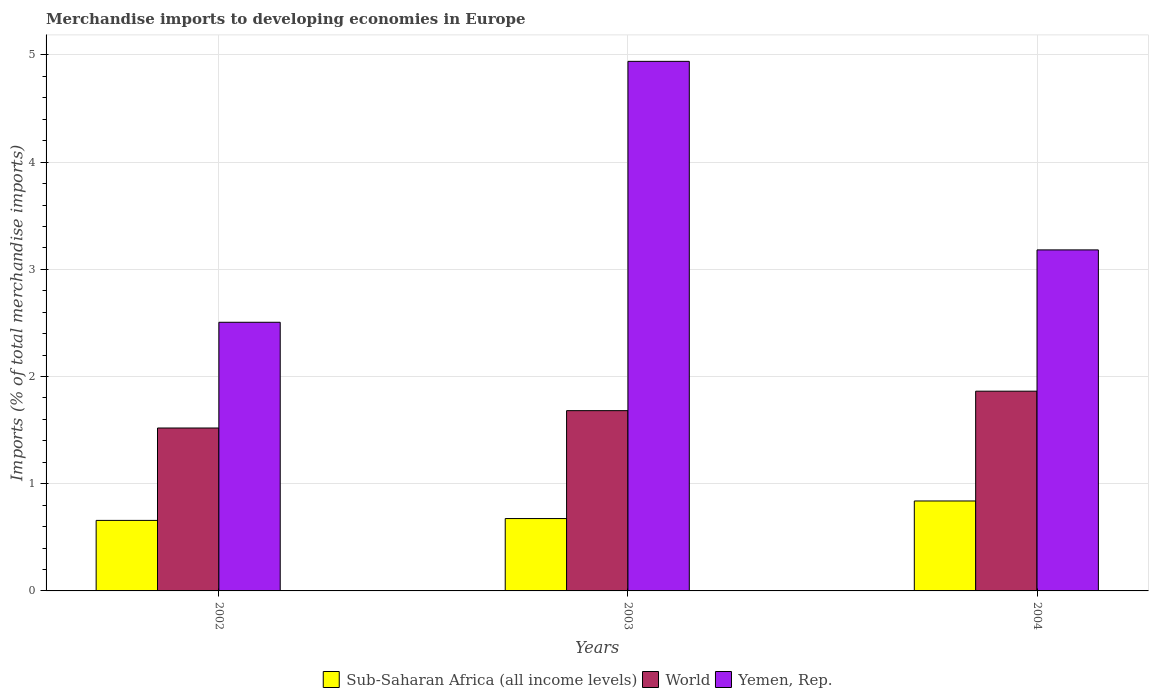How many groups of bars are there?
Ensure brevity in your answer.  3. Are the number of bars per tick equal to the number of legend labels?
Your answer should be very brief. Yes. How many bars are there on the 1st tick from the left?
Provide a succinct answer. 3. How many bars are there on the 3rd tick from the right?
Your response must be concise. 3. What is the label of the 3rd group of bars from the left?
Offer a very short reply. 2004. What is the percentage total merchandise imports in World in 2002?
Your answer should be very brief. 1.52. Across all years, what is the maximum percentage total merchandise imports in World?
Offer a terse response. 1.86. Across all years, what is the minimum percentage total merchandise imports in Sub-Saharan Africa (all income levels)?
Provide a short and direct response. 0.66. In which year was the percentage total merchandise imports in Sub-Saharan Africa (all income levels) maximum?
Your answer should be very brief. 2004. What is the total percentage total merchandise imports in World in the graph?
Offer a very short reply. 5.07. What is the difference between the percentage total merchandise imports in Sub-Saharan Africa (all income levels) in 2003 and that in 2004?
Provide a short and direct response. -0.16. What is the difference between the percentage total merchandise imports in World in 2002 and the percentage total merchandise imports in Sub-Saharan Africa (all income levels) in 2004?
Offer a very short reply. 0.68. What is the average percentage total merchandise imports in Yemen, Rep. per year?
Offer a terse response. 3.54. In the year 2002, what is the difference between the percentage total merchandise imports in Yemen, Rep. and percentage total merchandise imports in Sub-Saharan Africa (all income levels)?
Your answer should be compact. 1.85. What is the ratio of the percentage total merchandise imports in World in 2003 to that in 2004?
Your answer should be very brief. 0.9. What is the difference between the highest and the second highest percentage total merchandise imports in Sub-Saharan Africa (all income levels)?
Your answer should be compact. 0.16. What is the difference between the highest and the lowest percentage total merchandise imports in World?
Ensure brevity in your answer.  0.34. What does the 1st bar from the left in 2003 represents?
Your response must be concise. Sub-Saharan Africa (all income levels). What does the 1st bar from the right in 2002 represents?
Make the answer very short. Yemen, Rep. Are all the bars in the graph horizontal?
Your response must be concise. No. How many years are there in the graph?
Offer a very short reply. 3. What is the difference between two consecutive major ticks on the Y-axis?
Your response must be concise. 1. Does the graph contain grids?
Make the answer very short. Yes. What is the title of the graph?
Provide a succinct answer. Merchandise imports to developing economies in Europe. Does "Netherlands" appear as one of the legend labels in the graph?
Your response must be concise. No. What is the label or title of the X-axis?
Your response must be concise. Years. What is the label or title of the Y-axis?
Provide a short and direct response. Imports (% of total merchandise imports). What is the Imports (% of total merchandise imports) in Sub-Saharan Africa (all income levels) in 2002?
Your answer should be compact. 0.66. What is the Imports (% of total merchandise imports) in World in 2002?
Provide a short and direct response. 1.52. What is the Imports (% of total merchandise imports) in Yemen, Rep. in 2002?
Your answer should be very brief. 2.51. What is the Imports (% of total merchandise imports) in Sub-Saharan Africa (all income levels) in 2003?
Provide a succinct answer. 0.68. What is the Imports (% of total merchandise imports) in World in 2003?
Provide a short and direct response. 1.68. What is the Imports (% of total merchandise imports) of Yemen, Rep. in 2003?
Ensure brevity in your answer.  4.94. What is the Imports (% of total merchandise imports) of Sub-Saharan Africa (all income levels) in 2004?
Make the answer very short. 0.84. What is the Imports (% of total merchandise imports) in World in 2004?
Keep it short and to the point. 1.86. What is the Imports (% of total merchandise imports) in Yemen, Rep. in 2004?
Keep it short and to the point. 3.18. Across all years, what is the maximum Imports (% of total merchandise imports) in Sub-Saharan Africa (all income levels)?
Your response must be concise. 0.84. Across all years, what is the maximum Imports (% of total merchandise imports) of World?
Offer a very short reply. 1.86. Across all years, what is the maximum Imports (% of total merchandise imports) in Yemen, Rep.?
Provide a short and direct response. 4.94. Across all years, what is the minimum Imports (% of total merchandise imports) in Sub-Saharan Africa (all income levels)?
Give a very brief answer. 0.66. Across all years, what is the minimum Imports (% of total merchandise imports) in World?
Your response must be concise. 1.52. Across all years, what is the minimum Imports (% of total merchandise imports) in Yemen, Rep.?
Give a very brief answer. 2.51. What is the total Imports (% of total merchandise imports) in Sub-Saharan Africa (all income levels) in the graph?
Ensure brevity in your answer.  2.17. What is the total Imports (% of total merchandise imports) in World in the graph?
Your response must be concise. 5.07. What is the total Imports (% of total merchandise imports) in Yemen, Rep. in the graph?
Make the answer very short. 10.63. What is the difference between the Imports (% of total merchandise imports) in Sub-Saharan Africa (all income levels) in 2002 and that in 2003?
Offer a very short reply. -0.02. What is the difference between the Imports (% of total merchandise imports) of World in 2002 and that in 2003?
Your answer should be very brief. -0.16. What is the difference between the Imports (% of total merchandise imports) of Yemen, Rep. in 2002 and that in 2003?
Provide a succinct answer. -2.43. What is the difference between the Imports (% of total merchandise imports) in Sub-Saharan Africa (all income levels) in 2002 and that in 2004?
Make the answer very short. -0.18. What is the difference between the Imports (% of total merchandise imports) in World in 2002 and that in 2004?
Your answer should be very brief. -0.34. What is the difference between the Imports (% of total merchandise imports) in Yemen, Rep. in 2002 and that in 2004?
Keep it short and to the point. -0.68. What is the difference between the Imports (% of total merchandise imports) of Sub-Saharan Africa (all income levels) in 2003 and that in 2004?
Make the answer very short. -0.16. What is the difference between the Imports (% of total merchandise imports) in World in 2003 and that in 2004?
Make the answer very short. -0.18. What is the difference between the Imports (% of total merchandise imports) in Yemen, Rep. in 2003 and that in 2004?
Your response must be concise. 1.76. What is the difference between the Imports (% of total merchandise imports) in Sub-Saharan Africa (all income levels) in 2002 and the Imports (% of total merchandise imports) in World in 2003?
Provide a short and direct response. -1.02. What is the difference between the Imports (% of total merchandise imports) of Sub-Saharan Africa (all income levels) in 2002 and the Imports (% of total merchandise imports) of Yemen, Rep. in 2003?
Keep it short and to the point. -4.28. What is the difference between the Imports (% of total merchandise imports) in World in 2002 and the Imports (% of total merchandise imports) in Yemen, Rep. in 2003?
Give a very brief answer. -3.42. What is the difference between the Imports (% of total merchandise imports) in Sub-Saharan Africa (all income levels) in 2002 and the Imports (% of total merchandise imports) in World in 2004?
Make the answer very short. -1.21. What is the difference between the Imports (% of total merchandise imports) in Sub-Saharan Africa (all income levels) in 2002 and the Imports (% of total merchandise imports) in Yemen, Rep. in 2004?
Provide a succinct answer. -2.52. What is the difference between the Imports (% of total merchandise imports) in World in 2002 and the Imports (% of total merchandise imports) in Yemen, Rep. in 2004?
Give a very brief answer. -1.66. What is the difference between the Imports (% of total merchandise imports) in Sub-Saharan Africa (all income levels) in 2003 and the Imports (% of total merchandise imports) in World in 2004?
Offer a very short reply. -1.19. What is the difference between the Imports (% of total merchandise imports) in Sub-Saharan Africa (all income levels) in 2003 and the Imports (% of total merchandise imports) in Yemen, Rep. in 2004?
Give a very brief answer. -2.51. What is the difference between the Imports (% of total merchandise imports) in World in 2003 and the Imports (% of total merchandise imports) in Yemen, Rep. in 2004?
Your answer should be compact. -1.5. What is the average Imports (% of total merchandise imports) of Sub-Saharan Africa (all income levels) per year?
Give a very brief answer. 0.72. What is the average Imports (% of total merchandise imports) of World per year?
Offer a terse response. 1.69. What is the average Imports (% of total merchandise imports) of Yemen, Rep. per year?
Your response must be concise. 3.54. In the year 2002, what is the difference between the Imports (% of total merchandise imports) in Sub-Saharan Africa (all income levels) and Imports (% of total merchandise imports) in World?
Offer a terse response. -0.86. In the year 2002, what is the difference between the Imports (% of total merchandise imports) in Sub-Saharan Africa (all income levels) and Imports (% of total merchandise imports) in Yemen, Rep.?
Offer a terse response. -1.85. In the year 2002, what is the difference between the Imports (% of total merchandise imports) of World and Imports (% of total merchandise imports) of Yemen, Rep.?
Your answer should be compact. -0.99. In the year 2003, what is the difference between the Imports (% of total merchandise imports) in Sub-Saharan Africa (all income levels) and Imports (% of total merchandise imports) in World?
Provide a short and direct response. -1.01. In the year 2003, what is the difference between the Imports (% of total merchandise imports) in Sub-Saharan Africa (all income levels) and Imports (% of total merchandise imports) in Yemen, Rep.?
Offer a terse response. -4.27. In the year 2003, what is the difference between the Imports (% of total merchandise imports) of World and Imports (% of total merchandise imports) of Yemen, Rep.?
Provide a succinct answer. -3.26. In the year 2004, what is the difference between the Imports (% of total merchandise imports) in Sub-Saharan Africa (all income levels) and Imports (% of total merchandise imports) in World?
Ensure brevity in your answer.  -1.02. In the year 2004, what is the difference between the Imports (% of total merchandise imports) in Sub-Saharan Africa (all income levels) and Imports (% of total merchandise imports) in Yemen, Rep.?
Give a very brief answer. -2.34. In the year 2004, what is the difference between the Imports (% of total merchandise imports) of World and Imports (% of total merchandise imports) of Yemen, Rep.?
Ensure brevity in your answer.  -1.32. What is the ratio of the Imports (% of total merchandise imports) in Sub-Saharan Africa (all income levels) in 2002 to that in 2003?
Your answer should be compact. 0.97. What is the ratio of the Imports (% of total merchandise imports) in World in 2002 to that in 2003?
Your answer should be compact. 0.9. What is the ratio of the Imports (% of total merchandise imports) in Yemen, Rep. in 2002 to that in 2003?
Ensure brevity in your answer.  0.51. What is the ratio of the Imports (% of total merchandise imports) of Sub-Saharan Africa (all income levels) in 2002 to that in 2004?
Your answer should be very brief. 0.78. What is the ratio of the Imports (% of total merchandise imports) in World in 2002 to that in 2004?
Make the answer very short. 0.82. What is the ratio of the Imports (% of total merchandise imports) in Yemen, Rep. in 2002 to that in 2004?
Your answer should be compact. 0.79. What is the ratio of the Imports (% of total merchandise imports) in Sub-Saharan Africa (all income levels) in 2003 to that in 2004?
Your answer should be compact. 0.8. What is the ratio of the Imports (% of total merchandise imports) of World in 2003 to that in 2004?
Your response must be concise. 0.9. What is the ratio of the Imports (% of total merchandise imports) of Yemen, Rep. in 2003 to that in 2004?
Provide a succinct answer. 1.55. What is the difference between the highest and the second highest Imports (% of total merchandise imports) of Sub-Saharan Africa (all income levels)?
Provide a succinct answer. 0.16. What is the difference between the highest and the second highest Imports (% of total merchandise imports) of World?
Give a very brief answer. 0.18. What is the difference between the highest and the second highest Imports (% of total merchandise imports) in Yemen, Rep.?
Your response must be concise. 1.76. What is the difference between the highest and the lowest Imports (% of total merchandise imports) in Sub-Saharan Africa (all income levels)?
Your answer should be compact. 0.18. What is the difference between the highest and the lowest Imports (% of total merchandise imports) of World?
Give a very brief answer. 0.34. What is the difference between the highest and the lowest Imports (% of total merchandise imports) in Yemen, Rep.?
Offer a very short reply. 2.43. 